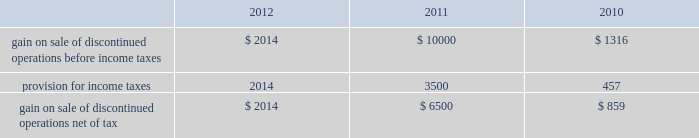Analog devices , inc .
Notes to consolidated financial statements 2014 ( continued ) asu no .
2011-05 is effective for fiscal years , and interim periods within those years , beginning after december 15 , 2011 , which is the company 2019s fiscal year 2013 .
Subsequently , in december 2011 , the fasb issued asu no .
2011-12 , deferral of the effective date for amendments to the presentation of reclassifications of items out of accumulated other comprehensive income in accounting standards update no .
2011-05 ( asu no .
2011-12 ) , which defers only those changes in asu no .
2011-05 that relate to the presentation of reclassification adjustments but does not affect all other requirements in asu no .
2011-05 .
The adoption of asu no .
2011-05 and asu no .
2011-12 will affect the presentation of comprehensive income but will not materially impact the company 2019s financial condition or results of operations .
Discontinued operations in november 2007 , the company entered into a purchase and sale agreement with certain subsidiaries of on semiconductor corporation to sell the company 2019s cpu voltage regulation and pc thermal monitoring business which consisted of core voltage regulator products for the central processing unit in computing and gaming applications and temperature sensors and fan-speed controllers for managing the temperature of the central processing unit .
During fiscal 2008 , the company completed the sale of this business .
In the first quarter of fiscal 2010 , proceeds of $ 1 million were released from escrow and $ 0.6 million net of tax was recorded as additional gain from the sale of discontinued operations .
The company does not expect any additional proceeds from this sale .
In september 2007 , the company entered into a definitive agreement to sell its baseband chipset business to mediatek inc .
The decision to sell the baseband chipset business was due to the company 2019s decision to focus its resources in areas where its signal processing expertise can provide unique capabilities and earn superior returns .
During fiscal 2008 , the company completed the sale of its baseband chipset business for net cash proceeds of $ 269 million .
The company made cash payments of $ 1.7 million during fiscal 2009 related to retention payments for employees who transferred to mediatek inc .
And for the reimbursement of intellectual property license fees incurred by mediatek .
During fiscal 2010 , the company received cash proceeds of $ 62 million as a result of the receipt of a refundable withholding tax and also recorded an additional gain on sale of $ 0.3 million , or $ 0.2 million net of tax , due to the settlement of certain items at less than the amounts accrued .
In fiscal 2011 , additional proceeds of $ 10 million were released from escrow and $ 6.5 million net of tax was recorded as additional gain from the sale of discontinued operations .
The company does not expect any additional proceeds from this sale .
The following amounts related to the cpu voltage regulation and pc thermal monitoring and baseband chipset businesses have been segregated from continuing operations and reported as discontinued operations. .
Stock-based compensation and shareholders 2019 equity equity compensation plans the company grants , or has granted , stock options and other stock and stock-based awards under the 2006 stock incentive plan ( 2006 plan ) .
The 2006 plan was approved by the company 2019s board of directors on january 23 , 2006 and was approved by shareholders on march 14 , 2006 and subsequently amended in march 2006 , june 2009 , september 2009 , december 2009 , december 2010 and june 2011 .
The 2006 plan provides for the grant of up to 15 million shares of the company 2019s common stock , plus such number of additional shares that were subject to outstanding options under the company 2019s previous plans that are not issued because the applicable option award subsequently terminates or expires without being exercised .
The 2006 plan provides for the grant of incentive stock options intended to qualify under section 422 of the internal revenue code of 1986 , as amended , non-statutory stock options , stock appreciation rights , restricted stock , restricted stock units and other stock-based awards .
Employees , officers , directors , consultants and advisors of the company and its subsidiaries are eligible to be granted awards under the 2006 plan .
No award may be made under the 2006 plan after march 13 , 2016 , but awards previously granted may extend beyond that date .
The company will not grant further options under any previous plans .
While the company may grant to employees options that become exercisable at different times or within different periods , the company has generally granted to employees options that vest over five years and become exercisable in annual installments of 20% ( 20 % ) on each of the first , second , third , fourth and fifth anniversaries of the date of grant ; 33.3% ( 33.3 % ) on each of the third , fourth , and fifth anniversaries of the date of grant ; or in annual installments of 25% ( 25 % ) on each of the second , third , fourth .
What is the effective income tax rate in 2011 based on the information about the gains on sales of discontinued operations? 
Computations: (3500 / 100000)
Answer: 0.035. 